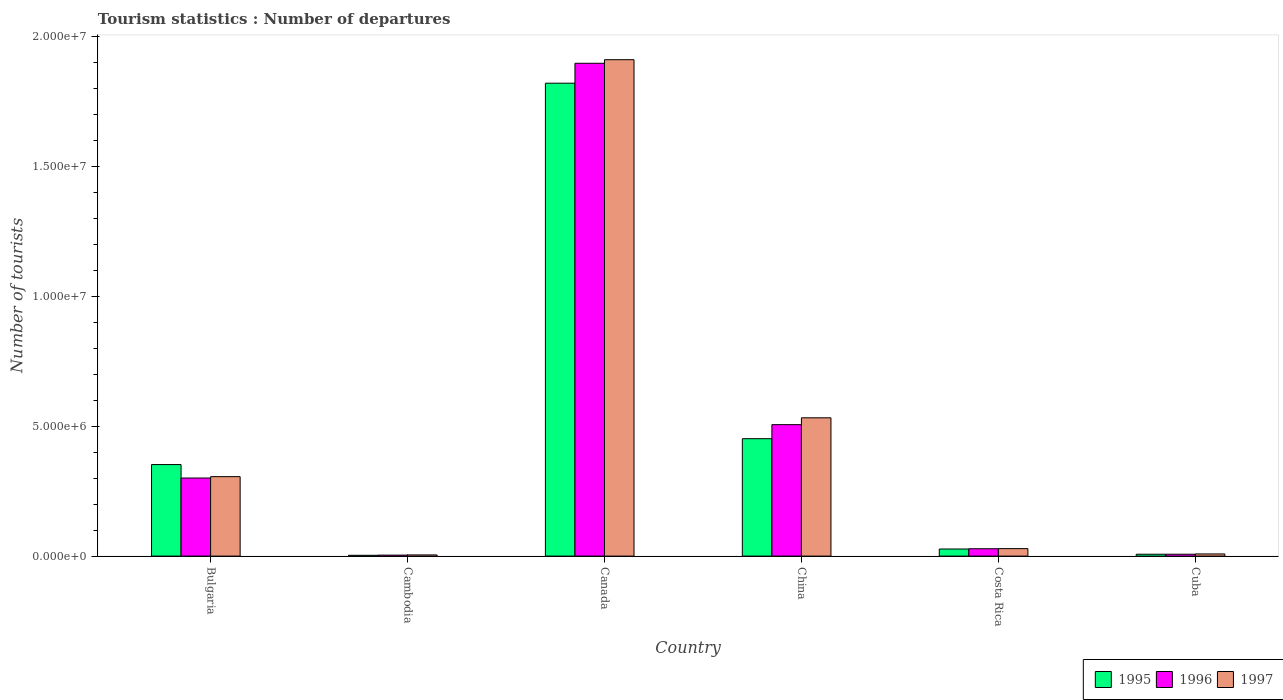How many different coloured bars are there?
Ensure brevity in your answer.  3. How many groups of bars are there?
Make the answer very short. 6. What is the number of tourist departures in 1997 in Canada?
Provide a succinct answer. 1.91e+07. Across all countries, what is the maximum number of tourist departures in 1995?
Offer a very short reply. 1.82e+07. Across all countries, what is the minimum number of tourist departures in 1996?
Provide a short and direct response. 3.80e+04. In which country was the number of tourist departures in 1997 maximum?
Give a very brief answer. Canada. In which country was the number of tourist departures in 1996 minimum?
Ensure brevity in your answer.  Cambodia. What is the total number of tourist departures in 1995 in the graph?
Your response must be concise. 2.66e+07. What is the difference between the number of tourist departures in 1997 in Cambodia and that in China?
Make the answer very short. -5.28e+06. What is the difference between the number of tourist departures in 1996 in Cuba and the number of tourist departures in 1995 in Cambodia?
Provide a succinct answer. 4.10e+04. What is the average number of tourist departures in 1996 per country?
Offer a terse response. 4.57e+06. What is the difference between the number of tourist departures of/in 1995 and number of tourist departures of/in 1996 in Canada?
Offer a terse response. -7.67e+05. In how many countries, is the number of tourist departures in 1997 greater than 17000000?
Your answer should be compact. 1. What is the ratio of the number of tourist departures in 1997 in Canada to that in Costa Rica?
Keep it short and to the point. 66.36. What is the difference between the highest and the second highest number of tourist departures in 1996?
Offer a terse response. 1.60e+07. What is the difference between the highest and the lowest number of tourist departures in 1995?
Give a very brief answer. 1.82e+07. Is the sum of the number of tourist departures in 1996 in Bulgaria and Cambodia greater than the maximum number of tourist departures in 1997 across all countries?
Keep it short and to the point. No. What does the 3rd bar from the left in China represents?
Give a very brief answer. 1997. What does the 2nd bar from the right in Costa Rica represents?
Ensure brevity in your answer.  1996. Is it the case that in every country, the sum of the number of tourist departures in 1996 and number of tourist departures in 1997 is greater than the number of tourist departures in 1995?
Make the answer very short. Yes. How many bars are there?
Offer a terse response. 18. Are all the bars in the graph horizontal?
Your answer should be very brief. No. What is the difference between two consecutive major ticks on the Y-axis?
Offer a very short reply. 5.00e+06. Does the graph contain grids?
Provide a short and direct response. No. Where does the legend appear in the graph?
Your answer should be compact. Bottom right. How many legend labels are there?
Make the answer very short. 3. What is the title of the graph?
Provide a succinct answer. Tourism statistics : Number of departures. What is the label or title of the X-axis?
Keep it short and to the point. Country. What is the label or title of the Y-axis?
Give a very brief answer. Number of tourists. What is the Number of tourists of 1995 in Bulgaria?
Offer a terse response. 3.52e+06. What is the Number of tourists of 1996 in Bulgaria?
Offer a terse response. 3.01e+06. What is the Number of tourists in 1997 in Bulgaria?
Your response must be concise. 3.06e+06. What is the Number of tourists of 1995 in Cambodia?
Offer a terse response. 3.10e+04. What is the Number of tourists of 1996 in Cambodia?
Offer a very short reply. 3.80e+04. What is the Number of tourists of 1997 in Cambodia?
Your answer should be very brief. 4.50e+04. What is the Number of tourists of 1995 in Canada?
Your answer should be very brief. 1.82e+07. What is the Number of tourists in 1996 in Canada?
Your response must be concise. 1.90e+07. What is the Number of tourists in 1997 in Canada?
Offer a very short reply. 1.91e+07. What is the Number of tourists in 1995 in China?
Provide a succinct answer. 4.52e+06. What is the Number of tourists of 1996 in China?
Offer a very short reply. 5.06e+06. What is the Number of tourists in 1997 in China?
Provide a short and direct response. 5.32e+06. What is the Number of tourists in 1995 in Costa Rica?
Keep it short and to the point. 2.73e+05. What is the Number of tourists of 1996 in Costa Rica?
Offer a very short reply. 2.83e+05. What is the Number of tourists in 1997 in Costa Rica?
Give a very brief answer. 2.88e+05. What is the Number of tourists in 1995 in Cuba?
Provide a short and direct response. 7.20e+04. What is the Number of tourists in 1996 in Cuba?
Ensure brevity in your answer.  7.20e+04. What is the Number of tourists of 1997 in Cuba?
Provide a short and direct response. 8.30e+04. Across all countries, what is the maximum Number of tourists in 1995?
Provide a short and direct response. 1.82e+07. Across all countries, what is the maximum Number of tourists in 1996?
Give a very brief answer. 1.90e+07. Across all countries, what is the maximum Number of tourists in 1997?
Your response must be concise. 1.91e+07. Across all countries, what is the minimum Number of tourists in 1995?
Provide a succinct answer. 3.10e+04. Across all countries, what is the minimum Number of tourists of 1996?
Keep it short and to the point. 3.80e+04. Across all countries, what is the minimum Number of tourists of 1997?
Your answer should be very brief. 4.50e+04. What is the total Number of tourists of 1995 in the graph?
Make the answer very short. 2.66e+07. What is the total Number of tourists in 1996 in the graph?
Your response must be concise. 2.74e+07. What is the total Number of tourists in 1997 in the graph?
Provide a succinct answer. 2.79e+07. What is the difference between the Number of tourists in 1995 in Bulgaria and that in Cambodia?
Keep it short and to the point. 3.49e+06. What is the difference between the Number of tourists in 1996 in Bulgaria and that in Cambodia?
Provide a short and direct response. 2.97e+06. What is the difference between the Number of tourists in 1997 in Bulgaria and that in Cambodia?
Provide a succinct answer. 3.01e+06. What is the difference between the Number of tourists of 1995 in Bulgaria and that in Canada?
Ensure brevity in your answer.  -1.47e+07. What is the difference between the Number of tourists of 1996 in Bulgaria and that in Canada?
Your response must be concise. -1.60e+07. What is the difference between the Number of tourists of 1997 in Bulgaria and that in Canada?
Make the answer very short. -1.61e+07. What is the difference between the Number of tourists in 1995 in Bulgaria and that in China?
Keep it short and to the point. -9.96e+05. What is the difference between the Number of tourists of 1996 in Bulgaria and that in China?
Make the answer very short. -2.06e+06. What is the difference between the Number of tourists in 1997 in Bulgaria and that in China?
Your answer should be very brief. -2.26e+06. What is the difference between the Number of tourists of 1995 in Bulgaria and that in Costa Rica?
Offer a very short reply. 3.25e+06. What is the difference between the Number of tourists in 1996 in Bulgaria and that in Costa Rica?
Give a very brief answer. 2.72e+06. What is the difference between the Number of tourists of 1997 in Bulgaria and that in Costa Rica?
Offer a very short reply. 2.77e+06. What is the difference between the Number of tourists in 1995 in Bulgaria and that in Cuba?
Your response must be concise. 3.45e+06. What is the difference between the Number of tourists of 1996 in Bulgaria and that in Cuba?
Offer a very short reply. 2.93e+06. What is the difference between the Number of tourists of 1997 in Bulgaria and that in Cuba?
Provide a short and direct response. 2.98e+06. What is the difference between the Number of tourists in 1995 in Cambodia and that in Canada?
Provide a succinct answer. -1.82e+07. What is the difference between the Number of tourists of 1996 in Cambodia and that in Canada?
Your response must be concise. -1.89e+07. What is the difference between the Number of tourists of 1997 in Cambodia and that in Canada?
Make the answer very short. -1.91e+07. What is the difference between the Number of tourists of 1995 in Cambodia and that in China?
Provide a short and direct response. -4.49e+06. What is the difference between the Number of tourists of 1996 in Cambodia and that in China?
Offer a very short reply. -5.02e+06. What is the difference between the Number of tourists of 1997 in Cambodia and that in China?
Keep it short and to the point. -5.28e+06. What is the difference between the Number of tourists of 1995 in Cambodia and that in Costa Rica?
Keep it short and to the point. -2.42e+05. What is the difference between the Number of tourists in 1996 in Cambodia and that in Costa Rica?
Your answer should be very brief. -2.45e+05. What is the difference between the Number of tourists in 1997 in Cambodia and that in Costa Rica?
Make the answer very short. -2.43e+05. What is the difference between the Number of tourists in 1995 in Cambodia and that in Cuba?
Your answer should be compact. -4.10e+04. What is the difference between the Number of tourists in 1996 in Cambodia and that in Cuba?
Your response must be concise. -3.40e+04. What is the difference between the Number of tourists in 1997 in Cambodia and that in Cuba?
Provide a succinct answer. -3.80e+04. What is the difference between the Number of tourists of 1995 in Canada and that in China?
Give a very brief answer. 1.37e+07. What is the difference between the Number of tourists of 1996 in Canada and that in China?
Keep it short and to the point. 1.39e+07. What is the difference between the Number of tourists of 1997 in Canada and that in China?
Offer a terse response. 1.38e+07. What is the difference between the Number of tourists of 1995 in Canada and that in Costa Rica?
Make the answer very short. 1.79e+07. What is the difference between the Number of tourists in 1996 in Canada and that in Costa Rica?
Ensure brevity in your answer.  1.87e+07. What is the difference between the Number of tourists in 1997 in Canada and that in Costa Rica?
Offer a very short reply. 1.88e+07. What is the difference between the Number of tourists of 1995 in Canada and that in Cuba?
Your answer should be compact. 1.81e+07. What is the difference between the Number of tourists in 1996 in Canada and that in Cuba?
Offer a terse response. 1.89e+07. What is the difference between the Number of tourists in 1997 in Canada and that in Cuba?
Keep it short and to the point. 1.90e+07. What is the difference between the Number of tourists in 1995 in China and that in Costa Rica?
Your answer should be compact. 4.25e+06. What is the difference between the Number of tourists in 1996 in China and that in Costa Rica?
Provide a succinct answer. 4.78e+06. What is the difference between the Number of tourists in 1997 in China and that in Costa Rica?
Provide a succinct answer. 5.04e+06. What is the difference between the Number of tourists in 1995 in China and that in Cuba?
Your response must be concise. 4.45e+06. What is the difference between the Number of tourists in 1996 in China and that in Cuba?
Ensure brevity in your answer.  4.99e+06. What is the difference between the Number of tourists in 1997 in China and that in Cuba?
Provide a succinct answer. 5.24e+06. What is the difference between the Number of tourists of 1995 in Costa Rica and that in Cuba?
Your answer should be very brief. 2.01e+05. What is the difference between the Number of tourists of 1996 in Costa Rica and that in Cuba?
Your response must be concise. 2.11e+05. What is the difference between the Number of tourists in 1997 in Costa Rica and that in Cuba?
Offer a terse response. 2.05e+05. What is the difference between the Number of tourists of 1995 in Bulgaria and the Number of tourists of 1996 in Cambodia?
Make the answer very short. 3.49e+06. What is the difference between the Number of tourists of 1995 in Bulgaria and the Number of tourists of 1997 in Cambodia?
Offer a terse response. 3.48e+06. What is the difference between the Number of tourists in 1996 in Bulgaria and the Number of tourists in 1997 in Cambodia?
Your answer should be very brief. 2.96e+06. What is the difference between the Number of tourists of 1995 in Bulgaria and the Number of tourists of 1996 in Canada?
Keep it short and to the point. -1.54e+07. What is the difference between the Number of tourists in 1995 in Bulgaria and the Number of tourists in 1997 in Canada?
Make the answer very short. -1.56e+07. What is the difference between the Number of tourists of 1996 in Bulgaria and the Number of tourists of 1997 in Canada?
Offer a terse response. -1.61e+07. What is the difference between the Number of tourists of 1995 in Bulgaria and the Number of tourists of 1996 in China?
Keep it short and to the point. -1.54e+06. What is the difference between the Number of tourists in 1995 in Bulgaria and the Number of tourists in 1997 in China?
Keep it short and to the point. -1.80e+06. What is the difference between the Number of tourists in 1996 in Bulgaria and the Number of tourists in 1997 in China?
Your answer should be very brief. -2.32e+06. What is the difference between the Number of tourists in 1995 in Bulgaria and the Number of tourists in 1996 in Costa Rica?
Your answer should be very brief. 3.24e+06. What is the difference between the Number of tourists of 1995 in Bulgaria and the Number of tourists of 1997 in Costa Rica?
Your answer should be compact. 3.24e+06. What is the difference between the Number of tourists in 1996 in Bulgaria and the Number of tourists in 1997 in Costa Rica?
Make the answer very short. 2.72e+06. What is the difference between the Number of tourists of 1995 in Bulgaria and the Number of tourists of 1996 in Cuba?
Provide a short and direct response. 3.45e+06. What is the difference between the Number of tourists of 1995 in Bulgaria and the Number of tourists of 1997 in Cuba?
Keep it short and to the point. 3.44e+06. What is the difference between the Number of tourists of 1996 in Bulgaria and the Number of tourists of 1997 in Cuba?
Your answer should be compact. 2.92e+06. What is the difference between the Number of tourists in 1995 in Cambodia and the Number of tourists in 1996 in Canada?
Offer a very short reply. -1.89e+07. What is the difference between the Number of tourists in 1995 in Cambodia and the Number of tourists in 1997 in Canada?
Ensure brevity in your answer.  -1.91e+07. What is the difference between the Number of tourists of 1996 in Cambodia and the Number of tourists of 1997 in Canada?
Give a very brief answer. -1.91e+07. What is the difference between the Number of tourists of 1995 in Cambodia and the Number of tourists of 1996 in China?
Your answer should be very brief. -5.03e+06. What is the difference between the Number of tourists in 1995 in Cambodia and the Number of tourists in 1997 in China?
Offer a terse response. -5.29e+06. What is the difference between the Number of tourists in 1996 in Cambodia and the Number of tourists in 1997 in China?
Give a very brief answer. -5.29e+06. What is the difference between the Number of tourists in 1995 in Cambodia and the Number of tourists in 1996 in Costa Rica?
Your answer should be compact. -2.52e+05. What is the difference between the Number of tourists in 1995 in Cambodia and the Number of tourists in 1997 in Costa Rica?
Your response must be concise. -2.57e+05. What is the difference between the Number of tourists of 1996 in Cambodia and the Number of tourists of 1997 in Costa Rica?
Your answer should be very brief. -2.50e+05. What is the difference between the Number of tourists of 1995 in Cambodia and the Number of tourists of 1996 in Cuba?
Your response must be concise. -4.10e+04. What is the difference between the Number of tourists in 1995 in Cambodia and the Number of tourists in 1997 in Cuba?
Provide a short and direct response. -5.20e+04. What is the difference between the Number of tourists in 1996 in Cambodia and the Number of tourists in 1997 in Cuba?
Your answer should be compact. -4.50e+04. What is the difference between the Number of tourists in 1995 in Canada and the Number of tourists in 1996 in China?
Your answer should be compact. 1.31e+07. What is the difference between the Number of tourists in 1995 in Canada and the Number of tourists in 1997 in China?
Make the answer very short. 1.29e+07. What is the difference between the Number of tourists of 1996 in Canada and the Number of tourists of 1997 in China?
Offer a very short reply. 1.36e+07. What is the difference between the Number of tourists of 1995 in Canada and the Number of tourists of 1996 in Costa Rica?
Your response must be concise. 1.79e+07. What is the difference between the Number of tourists of 1995 in Canada and the Number of tourists of 1997 in Costa Rica?
Your answer should be very brief. 1.79e+07. What is the difference between the Number of tourists in 1996 in Canada and the Number of tourists in 1997 in Costa Rica?
Offer a very short reply. 1.87e+07. What is the difference between the Number of tourists in 1995 in Canada and the Number of tourists in 1996 in Cuba?
Offer a very short reply. 1.81e+07. What is the difference between the Number of tourists in 1995 in Canada and the Number of tourists in 1997 in Cuba?
Provide a short and direct response. 1.81e+07. What is the difference between the Number of tourists of 1996 in Canada and the Number of tourists of 1997 in Cuba?
Your answer should be compact. 1.89e+07. What is the difference between the Number of tourists in 1995 in China and the Number of tourists in 1996 in Costa Rica?
Your response must be concise. 4.24e+06. What is the difference between the Number of tourists in 1995 in China and the Number of tourists in 1997 in Costa Rica?
Your answer should be very brief. 4.23e+06. What is the difference between the Number of tourists of 1996 in China and the Number of tourists of 1997 in Costa Rica?
Your response must be concise. 4.77e+06. What is the difference between the Number of tourists of 1995 in China and the Number of tourists of 1996 in Cuba?
Your answer should be very brief. 4.45e+06. What is the difference between the Number of tourists of 1995 in China and the Number of tourists of 1997 in Cuba?
Make the answer very short. 4.44e+06. What is the difference between the Number of tourists in 1996 in China and the Number of tourists in 1997 in Cuba?
Give a very brief answer. 4.98e+06. What is the difference between the Number of tourists of 1995 in Costa Rica and the Number of tourists of 1996 in Cuba?
Your response must be concise. 2.01e+05. What is the difference between the Number of tourists in 1995 in Costa Rica and the Number of tourists in 1997 in Cuba?
Offer a terse response. 1.90e+05. What is the average Number of tourists in 1995 per country?
Offer a terse response. 4.44e+06. What is the average Number of tourists in 1996 per country?
Keep it short and to the point. 4.57e+06. What is the average Number of tourists of 1997 per country?
Offer a very short reply. 4.65e+06. What is the difference between the Number of tourists of 1995 and Number of tourists of 1996 in Bulgaria?
Keep it short and to the point. 5.18e+05. What is the difference between the Number of tourists in 1995 and Number of tourists in 1997 in Bulgaria?
Make the answer very short. 4.65e+05. What is the difference between the Number of tourists of 1996 and Number of tourists of 1997 in Bulgaria?
Provide a succinct answer. -5.30e+04. What is the difference between the Number of tourists in 1995 and Number of tourists in 1996 in Cambodia?
Ensure brevity in your answer.  -7000. What is the difference between the Number of tourists of 1995 and Number of tourists of 1997 in Cambodia?
Offer a terse response. -1.40e+04. What is the difference between the Number of tourists in 1996 and Number of tourists in 1997 in Cambodia?
Give a very brief answer. -7000. What is the difference between the Number of tourists in 1995 and Number of tourists in 1996 in Canada?
Give a very brief answer. -7.67e+05. What is the difference between the Number of tourists in 1995 and Number of tourists in 1997 in Canada?
Your answer should be very brief. -9.05e+05. What is the difference between the Number of tourists in 1996 and Number of tourists in 1997 in Canada?
Offer a terse response. -1.38e+05. What is the difference between the Number of tourists in 1995 and Number of tourists in 1996 in China?
Give a very brief answer. -5.41e+05. What is the difference between the Number of tourists of 1995 and Number of tourists of 1997 in China?
Your response must be concise. -8.04e+05. What is the difference between the Number of tourists of 1996 and Number of tourists of 1997 in China?
Provide a short and direct response. -2.63e+05. What is the difference between the Number of tourists of 1995 and Number of tourists of 1997 in Costa Rica?
Ensure brevity in your answer.  -1.50e+04. What is the difference between the Number of tourists in 1996 and Number of tourists in 1997 in Costa Rica?
Give a very brief answer. -5000. What is the difference between the Number of tourists of 1995 and Number of tourists of 1996 in Cuba?
Provide a short and direct response. 0. What is the difference between the Number of tourists in 1995 and Number of tourists in 1997 in Cuba?
Ensure brevity in your answer.  -1.10e+04. What is the difference between the Number of tourists of 1996 and Number of tourists of 1997 in Cuba?
Offer a terse response. -1.10e+04. What is the ratio of the Number of tourists in 1995 in Bulgaria to that in Cambodia?
Offer a very short reply. 113.68. What is the ratio of the Number of tourists of 1996 in Bulgaria to that in Cambodia?
Your answer should be compact. 79.11. What is the ratio of the Number of tourists in 1997 in Bulgaria to that in Cambodia?
Provide a succinct answer. 67.98. What is the ratio of the Number of tourists in 1995 in Bulgaria to that in Canada?
Provide a succinct answer. 0.19. What is the ratio of the Number of tourists of 1996 in Bulgaria to that in Canada?
Provide a short and direct response. 0.16. What is the ratio of the Number of tourists in 1997 in Bulgaria to that in Canada?
Offer a very short reply. 0.16. What is the ratio of the Number of tourists in 1995 in Bulgaria to that in China?
Offer a terse response. 0.78. What is the ratio of the Number of tourists in 1996 in Bulgaria to that in China?
Make the answer very short. 0.59. What is the ratio of the Number of tourists of 1997 in Bulgaria to that in China?
Ensure brevity in your answer.  0.57. What is the ratio of the Number of tourists in 1995 in Bulgaria to that in Costa Rica?
Offer a terse response. 12.91. What is the ratio of the Number of tourists in 1996 in Bulgaria to that in Costa Rica?
Offer a terse response. 10.62. What is the ratio of the Number of tourists in 1997 in Bulgaria to that in Costa Rica?
Your response must be concise. 10.62. What is the ratio of the Number of tourists in 1995 in Bulgaria to that in Cuba?
Offer a very short reply. 48.94. What is the ratio of the Number of tourists in 1996 in Bulgaria to that in Cuba?
Ensure brevity in your answer.  41.75. What is the ratio of the Number of tourists of 1997 in Bulgaria to that in Cuba?
Your response must be concise. 36.86. What is the ratio of the Number of tourists in 1995 in Cambodia to that in Canada?
Offer a very short reply. 0. What is the ratio of the Number of tourists in 1996 in Cambodia to that in Canada?
Provide a short and direct response. 0. What is the ratio of the Number of tourists of 1997 in Cambodia to that in Canada?
Give a very brief answer. 0. What is the ratio of the Number of tourists in 1995 in Cambodia to that in China?
Give a very brief answer. 0.01. What is the ratio of the Number of tourists of 1996 in Cambodia to that in China?
Make the answer very short. 0.01. What is the ratio of the Number of tourists of 1997 in Cambodia to that in China?
Provide a short and direct response. 0.01. What is the ratio of the Number of tourists in 1995 in Cambodia to that in Costa Rica?
Give a very brief answer. 0.11. What is the ratio of the Number of tourists of 1996 in Cambodia to that in Costa Rica?
Offer a very short reply. 0.13. What is the ratio of the Number of tourists of 1997 in Cambodia to that in Costa Rica?
Your response must be concise. 0.16. What is the ratio of the Number of tourists of 1995 in Cambodia to that in Cuba?
Your response must be concise. 0.43. What is the ratio of the Number of tourists in 1996 in Cambodia to that in Cuba?
Provide a short and direct response. 0.53. What is the ratio of the Number of tourists of 1997 in Cambodia to that in Cuba?
Your answer should be compact. 0.54. What is the ratio of the Number of tourists in 1995 in Canada to that in China?
Provide a short and direct response. 4.03. What is the ratio of the Number of tourists of 1996 in Canada to that in China?
Offer a terse response. 3.75. What is the ratio of the Number of tourists in 1997 in Canada to that in China?
Provide a short and direct response. 3.59. What is the ratio of the Number of tourists in 1995 in Canada to that in Costa Rica?
Your answer should be very brief. 66.69. What is the ratio of the Number of tourists of 1996 in Canada to that in Costa Rica?
Keep it short and to the point. 67.04. What is the ratio of the Number of tourists in 1997 in Canada to that in Costa Rica?
Offer a terse response. 66.36. What is the ratio of the Number of tourists in 1995 in Canada to that in Cuba?
Offer a very short reply. 252.86. What is the ratio of the Number of tourists of 1996 in Canada to that in Cuba?
Provide a short and direct response. 263.51. What is the ratio of the Number of tourists of 1997 in Canada to that in Cuba?
Keep it short and to the point. 230.25. What is the ratio of the Number of tourists of 1995 in China to that in Costa Rica?
Make the answer very short. 16.56. What is the ratio of the Number of tourists of 1996 in China to that in Costa Rica?
Your answer should be compact. 17.88. What is the ratio of the Number of tourists of 1997 in China to that in Costa Rica?
Ensure brevity in your answer.  18.49. What is the ratio of the Number of tourists in 1995 in China to that in Cuba?
Your answer should be very brief. 62.78. What is the ratio of the Number of tourists in 1996 in China to that in Cuba?
Your answer should be very brief. 70.29. What is the ratio of the Number of tourists in 1997 in China to that in Cuba?
Your response must be concise. 64.14. What is the ratio of the Number of tourists in 1995 in Costa Rica to that in Cuba?
Keep it short and to the point. 3.79. What is the ratio of the Number of tourists in 1996 in Costa Rica to that in Cuba?
Your answer should be very brief. 3.93. What is the ratio of the Number of tourists in 1997 in Costa Rica to that in Cuba?
Provide a short and direct response. 3.47. What is the difference between the highest and the second highest Number of tourists of 1995?
Give a very brief answer. 1.37e+07. What is the difference between the highest and the second highest Number of tourists in 1996?
Make the answer very short. 1.39e+07. What is the difference between the highest and the second highest Number of tourists in 1997?
Your answer should be compact. 1.38e+07. What is the difference between the highest and the lowest Number of tourists in 1995?
Offer a terse response. 1.82e+07. What is the difference between the highest and the lowest Number of tourists of 1996?
Offer a very short reply. 1.89e+07. What is the difference between the highest and the lowest Number of tourists in 1997?
Give a very brief answer. 1.91e+07. 